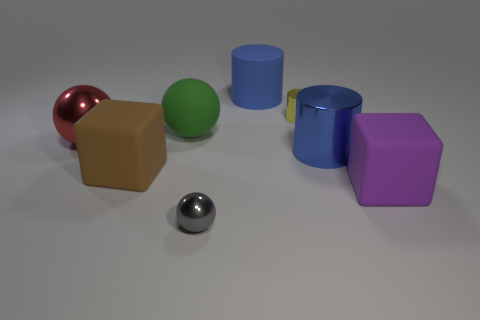Add 1 blue matte things. How many objects exist? 9 Subtract all spheres. How many objects are left? 5 Add 8 matte cubes. How many matte cubes are left? 10 Add 3 small blue matte things. How many small blue matte things exist? 3 Subtract 0 cyan spheres. How many objects are left? 8 Subtract all large red metal balls. Subtract all yellow shiny cylinders. How many objects are left? 6 